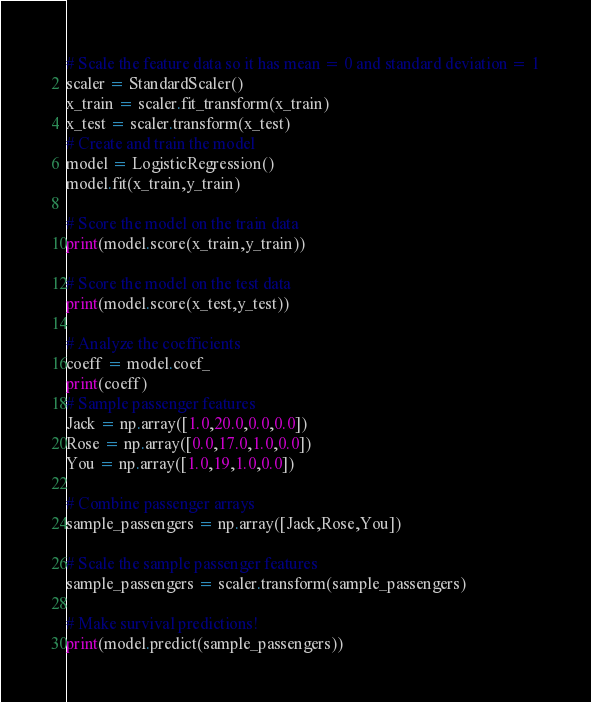<code> <loc_0><loc_0><loc_500><loc_500><_Python_>
# Scale the feature data so it has mean = 0 and standard deviation = 1
scaler = StandardScaler()
x_train = scaler.fit_transform(x_train)
x_test = scaler.transform(x_test)
# Create and train the model
model = LogisticRegression()
model.fit(x_train,y_train)

# Score the model on the train data
print(model.score(x_train,y_train))

# Score the model on the test data
print(model.score(x_test,y_test))

# Analyze the coefficients
coeff = model.coef_
print(coeff)
# Sample passenger features
Jack = np.array([1.0,20.0,0.0,0.0])
Rose = np.array([0.0,17.0,1.0,0.0])
You = np.array([1.0,19,1.0,0.0])

# Combine passenger arrays
sample_passengers = np.array([Jack,Rose,You])

# Scale the sample passenger features
sample_passengers = scaler.transform(sample_passengers)

# Make survival predictions!
print(model.predict(sample_passengers))

</code> 